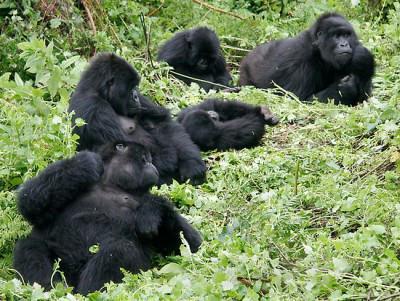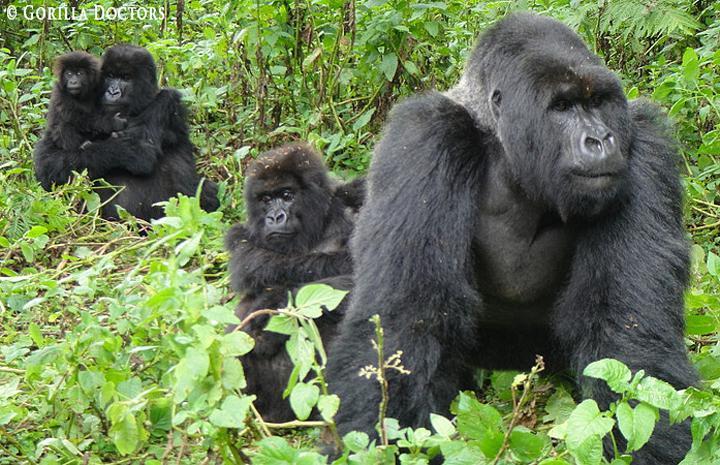The first image is the image on the left, the second image is the image on the right. Analyze the images presented: Is the assertion "There are at most 4 gorillas in one of the images." valid? Answer yes or no. Yes. 